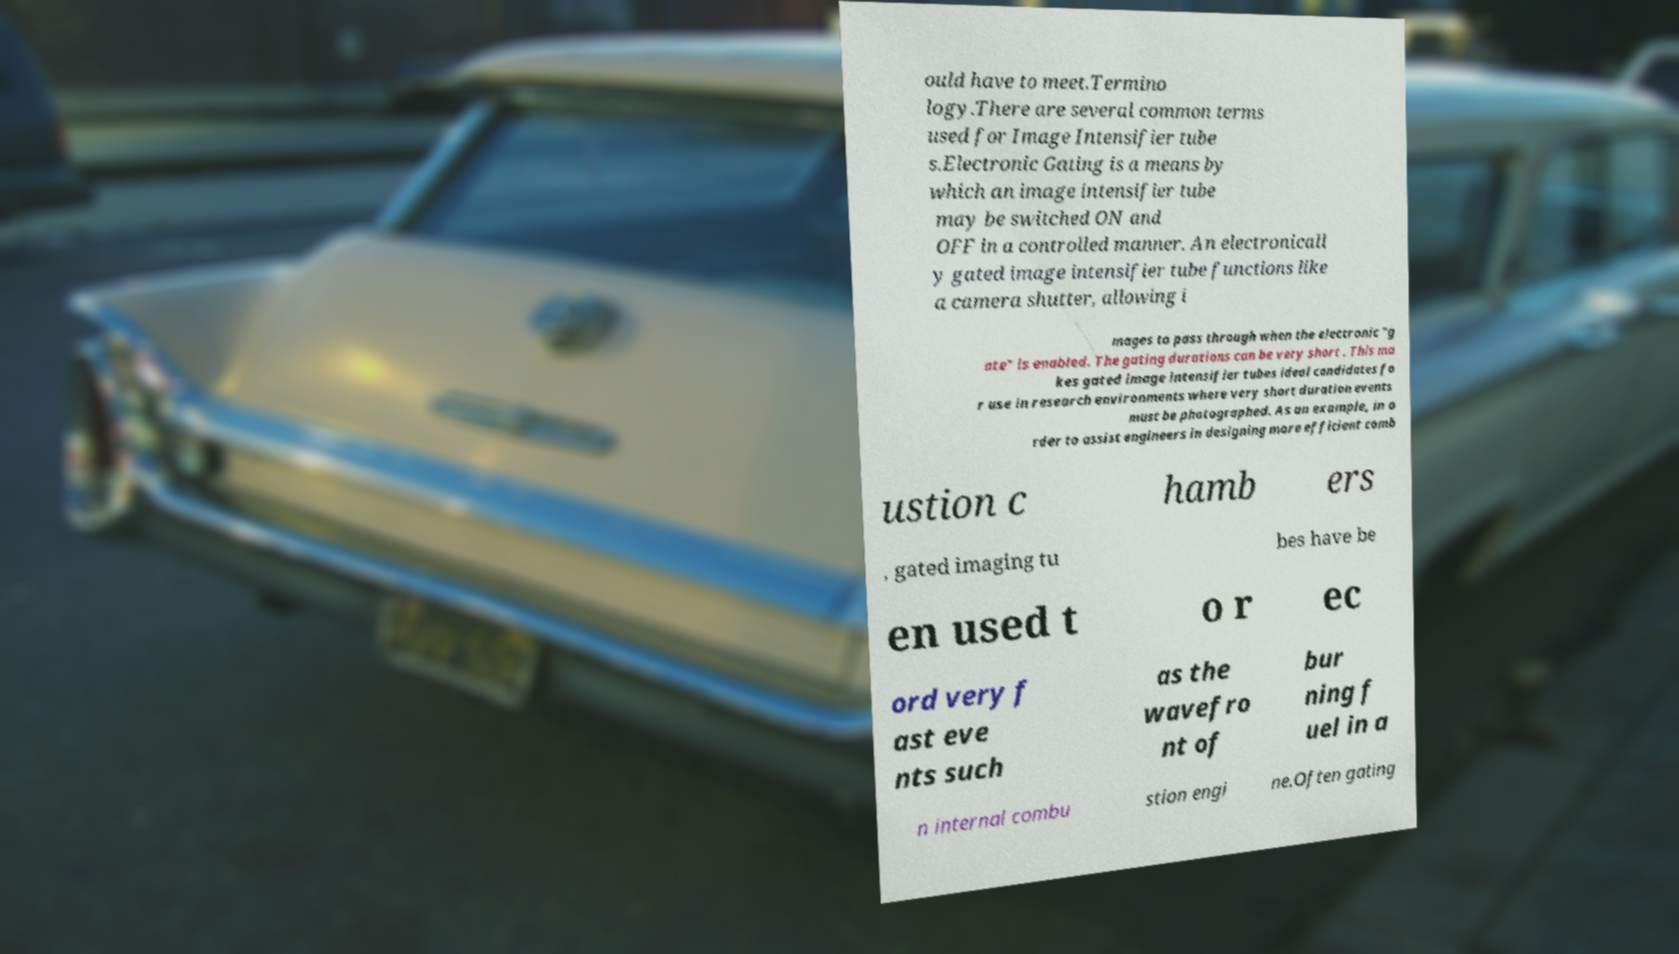For documentation purposes, I need the text within this image transcribed. Could you provide that? ould have to meet.Termino logy.There are several common terms used for Image Intensifier tube s.Electronic Gating is a means by which an image intensifier tube may be switched ON and OFF in a controlled manner. An electronicall y gated image intensifier tube functions like a camera shutter, allowing i mages to pass through when the electronic "g ate" is enabled. The gating durations can be very short . This ma kes gated image intensifier tubes ideal candidates fo r use in research environments where very short duration events must be photographed. As an example, in o rder to assist engineers in designing more efficient comb ustion c hamb ers , gated imaging tu bes have be en used t o r ec ord very f ast eve nts such as the wavefro nt of bur ning f uel in a n internal combu stion engi ne.Often gating 